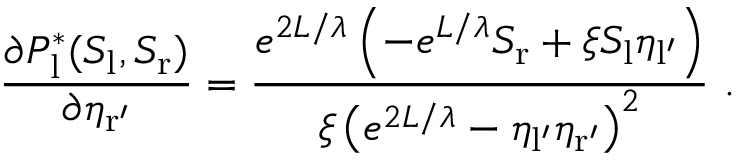<formula> <loc_0><loc_0><loc_500><loc_500>\frac { \partial P _ { l } ^ { * } ( S _ { l } , S _ { r } ) } { \partial \eta _ { r ^ { \prime } } } = \frac { e ^ { 2 L / \lambda } \left ( - e ^ { L / \lambda } S _ { r } + \xi S _ { l } \eta _ { l ^ { \prime } } \right ) } { \xi \left ( e ^ { 2 L / \lambda } - \eta _ { l ^ { \prime } } \eta _ { r ^ { \prime } } \right ) ^ { 2 } } \ .</formula> 